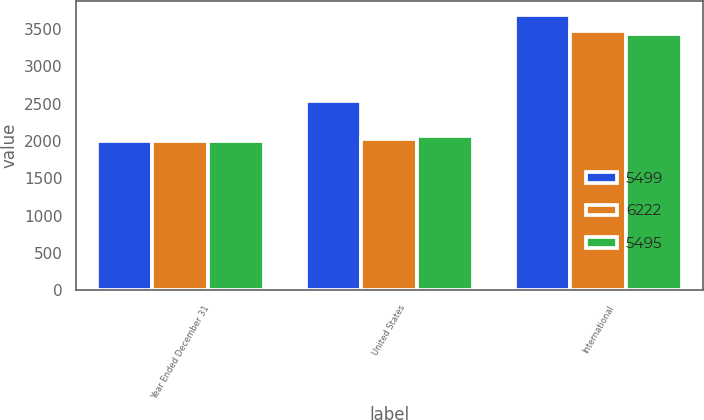Convert chart to OTSL. <chart><loc_0><loc_0><loc_500><loc_500><stacked_bar_chart><ecel><fcel>Year Ended December 31<fcel>United States<fcel>International<nl><fcel>5499<fcel>2004<fcel>2535<fcel>3687<nl><fcel>6222<fcel>2003<fcel>2029<fcel>3466<nl><fcel>5495<fcel>2002<fcel>2062<fcel>3437<nl></chart> 